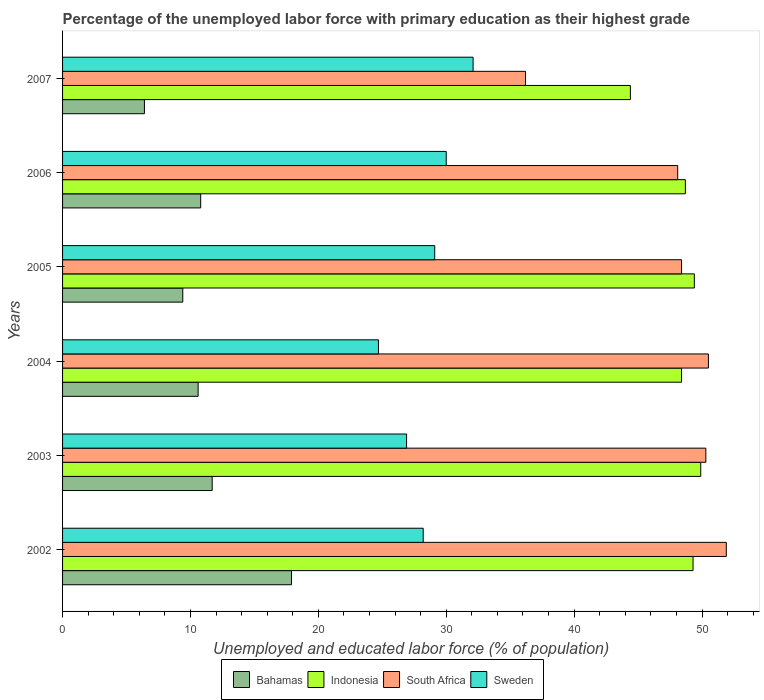How many different coloured bars are there?
Offer a very short reply. 4. Are the number of bars per tick equal to the number of legend labels?
Provide a succinct answer. Yes. Are the number of bars on each tick of the Y-axis equal?
Your answer should be very brief. Yes. How many bars are there on the 3rd tick from the top?
Make the answer very short. 4. What is the label of the 3rd group of bars from the top?
Give a very brief answer. 2005. What is the percentage of the unemployed labor force with primary education in Indonesia in 2002?
Provide a short and direct response. 49.3. Across all years, what is the maximum percentage of the unemployed labor force with primary education in Sweden?
Keep it short and to the point. 32.1. Across all years, what is the minimum percentage of the unemployed labor force with primary education in South Africa?
Ensure brevity in your answer.  36.2. In which year was the percentage of the unemployed labor force with primary education in South Africa minimum?
Offer a terse response. 2007. What is the total percentage of the unemployed labor force with primary education in Bahamas in the graph?
Your answer should be compact. 66.8. What is the difference between the percentage of the unemployed labor force with primary education in Bahamas in 2002 and that in 2005?
Keep it short and to the point. 8.5. What is the difference between the percentage of the unemployed labor force with primary education in Sweden in 2006 and the percentage of the unemployed labor force with primary education in South Africa in 2007?
Ensure brevity in your answer.  -6.2. What is the average percentage of the unemployed labor force with primary education in Sweden per year?
Provide a succinct answer. 28.5. In the year 2004, what is the difference between the percentage of the unemployed labor force with primary education in Indonesia and percentage of the unemployed labor force with primary education in Bahamas?
Make the answer very short. 37.8. In how many years, is the percentage of the unemployed labor force with primary education in Sweden greater than 32 %?
Offer a very short reply. 1. What is the ratio of the percentage of the unemployed labor force with primary education in South Africa in 2003 to that in 2007?
Give a very brief answer. 1.39. Is the percentage of the unemployed labor force with primary education in South Africa in 2005 less than that in 2006?
Keep it short and to the point. No. What is the difference between the highest and the second highest percentage of the unemployed labor force with primary education in Bahamas?
Ensure brevity in your answer.  6.2. What is the difference between the highest and the lowest percentage of the unemployed labor force with primary education in South Africa?
Provide a short and direct response. 15.7. In how many years, is the percentage of the unemployed labor force with primary education in Indonesia greater than the average percentage of the unemployed labor force with primary education in Indonesia taken over all years?
Provide a short and direct response. 5. Is the sum of the percentage of the unemployed labor force with primary education in South Africa in 2003 and 2007 greater than the maximum percentage of the unemployed labor force with primary education in Bahamas across all years?
Provide a succinct answer. Yes. Is it the case that in every year, the sum of the percentage of the unemployed labor force with primary education in South Africa and percentage of the unemployed labor force with primary education in Bahamas is greater than the sum of percentage of the unemployed labor force with primary education in Sweden and percentage of the unemployed labor force with primary education in Indonesia?
Ensure brevity in your answer.  Yes. What does the 2nd bar from the bottom in 2006 represents?
Make the answer very short. Indonesia. What is the difference between two consecutive major ticks on the X-axis?
Your answer should be very brief. 10. Are the values on the major ticks of X-axis written in scientific E-notation?
Make the answer very short. No. Does the graph contain any zero values?
Keep it short and to the point. No. Where does the legend appear in the graph?
Your answer should be compact. Bottom center. How many legend labels are there?
Ensure brevity in your answer.  4. What is the title of the graph?
Your response must be concise. Percentage of the unemployed labor force with primary education as their highest grade. What is the label or title of the X-axis?
Offer a very short reply. Unemployed and educated labor force (% of population). What is the label or title of the Y-axis?
Offer a very short reply. Years. What is the Unemployed and educated labor force (% of population) of Bahamas in 2002?
Ensure brevity in your answer.  17.9. What is the Unemployed and educated labor force (% of population) in Indonesia in 2002?
Make the answer very short. 49.3. What is the Unemployed and educated labor force (% of population) in South Africa in 2002?
Your answer should be very brief. 51.9. What is the Unemployed and educated labor force (% of population) of Sweden in 2002?
Offer a very short reply. 28.2. What is the Unemployed and educated labor force (% of population) in Bahamas in 2003?
Your answer should be very brief. 11.7. What is the Unemployed and educated labor force (% of population) in Indonesia in 2003?
Make the answer very short. 49.9. What is the Unemployed and educated labor force (% of population) in South Africa in 2003?
Keep it short and to the point. 50.3. What is the Unemployed and educated labor force (% of population) in Sweden in 2003?
Offer a terse response. 26.9. What is the Unemployed and educated labor force (% of population) of Bahamas in 2004?
Your answer should be compact. 10.6. What is the Unemployed and educated labor force (% of population) of Indonesia in 2004?
Give a very brief answer. 48.4. What is the Unemployed and educated labor force (% of population) in South Africa in 2004?
Ensure brevity in your answer.  50.5. What is the Unemployed and educated labor force (% of population) in Sweden in 2004?
Provide a succinct answer. 24.7. What is the Unemployed and educated labor force (% of population) of Bahamas in 2005?
Offer a terse response. 9.4. What is the Unemployed and educated labor force (% of population) of Indonesia in 2005?
Give a very brief answer. 49.4. What is the Unemployed and educated labor force (% of population) in South Africa in 2005?
Your answer should be very brief. 48.4. What is the Unemployed and educated labor force (% of population) in Sweden in 2005?
Provide a succinct answer. 29.1. What is the Unemployed and educated labor force (% of population) of Bahamas in 2006?
Provide a short and direct response. 10.8. What is the Unemployed and educated labor force (% of population) in Indonesia in 2006?
Your answer should be very brief. 48.7. What is the Unemployed and educated labor force (% of population) in South Africa in 2006?
Offer a terse response. 48.1. What is the Unemployed and educated labor force (% of population) in Sweden in 2006?
Ensure brevity in your answer.  30. What is the Unemployed and educated labor force (% of population) in Bahamas in 2007?
Make the answer very short. 6.4. What is the Unemployed and educated labor force (% of population) in Indonesia in 2007?
Ensure brevity in your answer.  44.4. What is the Unemployed and educated labor force (% of population) in South Africa in 2007?
Offer a very short reply. 36.2. What is the Unemployed and educated labor force (% of population) of Sweden in 2007?
Your response must be concise. 32.1. Across all years, what is the maximum Unemployed and educated labor force (% of population) in Bahamas?
Ensure brevity in your answer.  17.9. Across all years, what is the maximum Unemployed and educated labor force (% of population) of Indonesia?
Ensure brevity in your answer.  49.9. Across all years, what is the maximum Unemployed and educated labor force (% of population) of South Africa?
Ensure brevity in your answer.  51.9. Across all years, what is the maximum Unemployed and educated labor force (% of population) of Sweden?
Ensure brevity in your answer.  32.1. Across all years, what is the minimum Unemployed and educated labor force (% of population) in Bahamas?
Ensure brevity in your answer.  6.4. Across all years, what is the minimum Unemployed and educated labor force (% of population) in Indonesia?
Keep it short and to the point. 44.4. Across all years, what is the minimum Unemployed and educated labor force (% of population) in South Africa?
Offer a terse response. 36.2. Across all years, what is the minimum Unemployed and educated labor force (% of population) in Sweden?
Offer a terse response. 24.7. What is the total Unemployed and educated labor force (% of population) in Bahamas in the graph?
Offer a very short reply. 66.8. What is the total Unemployed and educated labor force (% of population) of Indonesia in the graph?
Offer a very short reply. 290.1. What is the total Unemployed and educated labor force (% of population) of South Africa in the graph?
Give a very brief answer. 285.4. What is the total Unemployed and educated labor force (% of population) of Sweden in the graph?
Your answer should be very brief. 171. What is the difference between the Unemployed and educated labor force (% of population) of Bahamas in 2002 and that in 2003?
Make the answer very short. 6.2. What is the difference between the Unemployed and educated labor force (% of population) in Sweden in 2002 and that in 2003?
Your response must be concise. 1.3. What is the difference between the Unemployed and educated labor force (% of population) in Indonesia in 2002 and that in 2004?
Your answer should be very brief. 0.9. What is the difference between the Unemployed and educated labor force (% of population) of South Africa in 2002 and that in 2004?
Your response must be concise. 1.4. What is the difference between the Unemployed and educated labor force (% of population) of Indonesia in 2002 and that in 2005?
Offer a terse response. -0.1. What is the difference between the Unemployed and educated labor force (% of population) in Sweden in 2002 and that in 2005?
Provide a short and direct response. -0.9. What is the difference between the Unemployed and educated labor force (% of population) of Indonesia in 2002 and that in 2006?
Keep it short and to the point. 0.6. What is the difference between the Unemployed and educated labor force (% of population) in Sweden in 2002 and that in 2006?
Your response must be concise. -1.8. What is the difference between the Unemployed and educated labor force (% of population) of Indonesia in 2002 and that in 2007?
Keep it short and to the point. 4.9. What is the difference between the Unemployed and educated labor force (% of population) of South Africa in 2003 and that in 2004?
Give a very brief answer. -0.2. What is the difference between the Unemployed and educated labor force (% of population) of Sweden in 2003 and that in 2004?
Your answer should be very brief. 2.2. What is the difference between the Unemployed and educated labor force (% of population) in South Africa in 2003 and that in 2005?
Provide a short and direct response. 1.9. What is the difference between the Unemployed and educated labor force (% of population) in Sweden in 2003 and that in 2005?
Your answer should be very brief. -2.2. What is the difference between the Unemployed and educated labor force (% of population) of Bahamas in 2003 and that in 2006?
Your answer should be compact. 0.9. What is the difference between the Unemployed and educated labor force (% of population) of Indonesia in 2003 and that in 2006?
Provide a succinct answer. 1.2. What is the difference between the Unemployed and educated labor force (% of population) of Sweden in 2003 and that in 2006?
Provide a short and direct response. -3.1. What is the difference between the Unemployed and educated labor force (% of population) in Bahamas in 2004 and that in 2005?
Your response must be concise. 1.2. What is the difference between the Unemployed and educated labor force (% of population) in South Africa in 2004 and that in 2005?
Offer a terse response. 2.1. What is the difference between the Unemployed and educated labor force (% of population) of Sweden in 2004 and that in 2005?
Provide a short and direct response. -4.4. What is the difference between the Unemployed and educated labor force (% of population) of Indonesia in 2004 and that in 2006?
Offer a terse response. -0.3. What is the difference between the Unemployed and educated labor force (% of population) of South Africa in 2004 and that in 2006?
Give a very brief answer. 2.4. What is the difference between the Unemployed and educated labor force (% of population) in Bahamas in 2004 and that in 2007?
Keep it short and to the point. 4.2. What is the difference between the Unemployed and educated labor force (% of population) in South Africa in 2004 and that in 2007?
Offer a very short reply. 14.3. What is the difference between the Unemployed and educated labor force (% of population) of Sweden in 2004 and that in 2007?
Provide a succinct answer. -7.4. What is the difference between the Unemployed and educated labor force (% of population) of Bahamas in 2005 and that in 2007?
Offer a very short reply. 3. What is the difference between the Unemployed and educated labor force (% of population) in Indonesia in 2005 and that in 2007?
Give a very brief answer. 5. What is the difference between the Unemployed and educated labor force (% of population) in Sweden in 2005 and that in 2007?
Your answer should be very brief. -3. What is the difference between the Unemployed and educated labor force (% of population) of Bahamas in 2006 and that in 2007?
Your answer should be very brief. 4.4. What is the difference between the Unemployed and educated labor force (% of population) of South Africa in 2006 and that in 2007?
Keep it short and to the point. 11.9. What is the difference between the Unemployed and educated labor force (% of population) of Sweden in 2006 and that in 2007?
Your response must be concise. -2.1. What is the difference between the Unemployed and educated labor force (% of population) of Bahamas in 2002 and the Unemployed and educated labor force (% of population) of Indonesia in 2003?
Offer a very short reply. -32. What is the difference between the Unemployed and educated labor force (% of population) of Bahamas in 2002 and the Unemployed and educated labor force (% of population) of South Africa in 2003?
Provide a succinct answer. -32.4. What is the difference between the Unemployed and educated labor force (% of population) in Indonesia in 2002 and the Unemployed and educated labor force (% of population) in Sweden in 2003?
Your answer should be compact. 22.4. What is the difference between the Unemployed and educated labor force (% of population) of Bahamas in 2002 and the Unemployed and educated labor force (% of population) of Indonesia in 2004?
Your answer should be compact. -30.5. What is the difference between the Unemployed and educated labor force (% of population) in Bahamas in 2002 and the Unemployed and educated labor force (% of population) in South Africa in 2004?
Ensure brevity in your answer.  -32.6. What is the difference between the Unemployed and educated labor force (% of population) in Indonesia in 2002 and the Unemployed and educated labor force (% of population) in Sweden in 2004?
Provide a succinct answer. 24.6. What is the difference between the Unemployed and educated labor force (% of population) in South Africa in 2002 and the Unemployed and educated labor force (% of population) in Sweden in 2004?
Provide a short and direct response. 27.2. What is the difference between the Unemployed and educated labor force (% of population) of Bahamas in 2002 and the Unemployed and educated labor force (% of population) of Indonesia in 2005?
Provide a short and direct response. -31.5. What is the difference between the Unemployed and educated labor force (% of population) of Bahamas in 2002 and the Unemployed and educated labor force (% of population) of South Africa in 2005?
Your answer should be compact. -30.5. What is the difference between the Unemployed and educated labor force (% of population) of Indonesia in 2002 and the Unemployed and educated labor force (% of population) of South Africa in 2005?
Make the answer very short. 0.9. What is the difference between the Unemployed and educated labor force (% of population) of Indonesia in 2002 and the Unemployed and educated labor force (% of population) of Sweden in 2005?
Your answer should be compact. 20.2. What is the difference between the Unemployed and educated labor force (% of population) of South Africa in 2002 and the Unemployed and educated labor force (% of population) of Sweden in 2005?
Your answer should be very brief. 22.8. What is the difference between the Unemployed and educated labor force (% of population) in Bahamas in 2002 and the Unemployed and educated labor force (% of population) in Indonesia in 2006?
Ensure brevity in your answer.  -30.8. What is the difference between the Unemployed and educated labor force (% of population) in Bahamas in 2002 and the Unemployed and educated labor force (% of population) in South Africa in 2006?
Your answer should be very brief. -30.2. What is the difference between the Unemployed and educated labor force (% of population) in Indonesia in 2002 and the Unemployed and educated labor force (% of population) in Sweden in 2006?
Provide a short and direct response. 19.3. What is the difference between the Unemployed and educated labor force (% of population) of South Africa in 2002 and the Unemployed and educated labor force (% of population) of Sweden in 2006?
Your response must be concise. 21.9. What is the difference between the Unemployed and educated labor force (% of population) of Bahamas in 2002 and the Unemployed and educated labor force (% of population) of Indonesia in 2007?
Ensure brevity in your answer.  -26.5. What is the difference between the Unemployed and educated labor force (% of population) of Bahamas in 2002 and the Unemployed and educated labor force (% of population) of South Africa in 2007?
Your answer should be very brief. -18.3. What is the difference between the Unemployed and educated labor force (% of population) in Bahamas in 2002 and the Unemployed and educated labor force (% of population) in Sweden in 2007?
Ensure brevity in your answer.  -14.2. What is the difference between the Unemployed and educated labor force (% of population) of South Africa in 2002 and the Unemployed and educated labor force (% of population) of Sweden in 2007?
Give a very brief answer. 19.8. What is the difference between the Unemployed and educated labor force (% of population) of Bahamas in 2003 and the Unemployed and educated labor force (% of population) of Indonesia in 2004?
Ensure brevity in your answer.  -36.7. What is the difference between the Unemployed and educated labor force (% of population) in Bahamas in 2003 and the Unemployed and educated labor force (% of population) in South Africa in 2004?
Provide a succinct answer. -38.8. What is the difference between the Unemployed and educated labor force (% of population) in Bahamas in 2003 and the Unemployed and educated labor force (% of population) in Sweden in 2004?
Ensure brevity in your answer.  -13. What is the difference between the Unemployed and educated labor force (% of population) of Indonesia in 2003 and the Unemployed and educated labor force (% of population) of Sweden in 2004?
Your answer should be very brief. 25.2. What is the difference between the Unemployed and educated labor force (% of population) in South Africa in 2003 and the Unemployed and educated labor force (% of population) in Sweden in 2004?
Offer a terse response. 25.6. What is the difference between the Unemployed and educated labor force (% of population) of Bahamas in 2003 and the Unemployed and educated labor force (% of population) of Indonesia in 2005?
Keep it short and to the point. -37.7. What is the difference between the Unemployed and educated labor force (% of population) in Bahamas in 2003 and the Unemployed and educated labor force (% of population) in South Africa in 2005?
Your answer should be compact. -36.7. What is the difference between the Unemployed and educated labor force (% of population) of Bahamas in 2003 and the Unemployed and educated labor force (% of population) of Sweden in 2005?
Keep it short and to the point. -17.4. What is the difference between the Unemployed and educated labor force (% of population) in Indonesia in 2003 and the Unemployed and educated labor force (% of population) in Sweden in 2005?
Ensure brevity in your answer.  20.8. What is the difference between the Unemployed and educated labor force (% of population) in South Africa in 2003 and the Unemployed and educated labor force (% of population) in Sweden in 2005?
Ensure brevity in your answer.  21.2. What is the difference between the Unemployed and educated labor force (% of population) of Bahamas in 2003 and the Unemployed and educated labor force (% of population) of Indonesia in 2006?
Make the answer very short. -37. What is the difference between the Unemployed and educated labor force (% of population) of Bahamas in 2003 and the Unemployed and educated labor force (% of population) of South Africa in 2006?
Your response must be concise. -36.4. What is the difference between the Unemployed and educated labor force (% of population) of Bahamas in 2003 and the Unemployed and educated labor force (% of population) of Sweden in 2006?
Give a very brief answer. -18.3. What is the difference between the Unemployed and educated labor force (% of population) of Indonesia in 2003 and the Unemployed and educated labor force (% of population) of South Africa in 2006?
Provide a succinct answer. 1.8. What is the difference between the Unemployed and educated labor force (% of population) in South Africa in 2003 and the Unemployed and educated labor force (% of population) in Sweden in 2006?
Keep it short and to the point. 20.3. What is the difference between the Unemployed and educated labor force (% of population) in Bahamas in 2003 and the Unemployed and educated labor force (% of population) in Indonesia in 2007?
Your answer should be very brief. -32.7. What is the difference between the Unemployed and educated labor force (% of population) in Bahamas in 2003 and the Unemployed and educated labor force (% of population) in South Africa in 2007?
Your answer should be compact. -24.5. What is the difference between the Unemployed and educated labor force (% of population) of Bahamas in 2003 and the Unemployed and educated labor force (% of population) of Sweden in 2007?
Make the answer very short. -20.4. What is the difference between the Unemployed and educated labor force (% of population) in Indonesia in 2003 and the Unemployed and educated labor force (% of population) in Sweden in 2007?
Your answer should be compact. 17.8. What is the difference between the Unemployed and educated labor force (% of population) of Bahamas in 2004 and the Unemployed and educated labor force (% of population) of Indonesia in 2005?
Make the answer very short. -38.8. What is the difference between the Unemployed and educated labor force (% of population) in Bahamas in 2004 and the Unemployed and educated labor force (% of population) in South Africa in 2005?
Give a very brief answer. -37.8. What is the difference between the Unemployed and educated labor force (% of population) in Bahamas in 2004 and the Unemployed and educated labor force (% of population) in Sweden in 2005?
Ensure brevity in your answer.  -18.5. What is the difference between the Unemployed and educated labor force (% of population) in Indonesia in 2004 and the Unemployed and educated labor force (% of population) in Sweden in 2005?
Your answer should be compact. 19.3. What is the difference between the Unemployed and educated labor force (% of population) of South Africa in 2004 and the Unemployed and educated labor force (% of population) of Sweden in 2005?
Make the answer very short. 21.4. What is the difference between the Unemployed and educated labor force (% of population) of Bahamas in 2004 and the Unemployed and educated labor force (% of population) of Indonesia in 2006?
Offer a terse response. -38.1. What is the difference between the Unemployed and educated labor force (% of population) of Bahamas in 2004 and the Unemployed and educated labor force (% of population) of South Africa in 2006?
Offer a terse response. -37.5. What is the difference between the Unemployed and educated labor force (% of population) in Bahamas in 2004 and the Unemployed and educated labor force (% of population) in Sweden in 2006?
Your answer should be compact. -19.4. What is the difference between the Unemployed and educated labor force (% of population) of Indonesia in 2004 and the Unemployed and educated labor force (% of population) of South Africa in 2006?
Your answer should be compact. 0.3. What is the difference between the Unemployed and educated labor force (% of population) in Indonesia in 2004 and the Unemployed and educated labor force (% of population) in Sweden in 2006?
Make the answer very short. 18.4. What is the difference between the Unemployed and educated labor force (% of population) in Bahamas in 2004 and the Unemployed and educated labor force (% of population) in Indonesia in 2007?
Your answer should be very brief. -33.8. What is the difference between the Unemployed and educated labor force (% of population) in Bahamas in 2004 and the Unemployed and educated labor force (% of population) in South Africa in 2007?
Give a very brief answer. -25.6. What is the difference between the Unemployed and educated labor force (% of population) of Bahamas in 2004 and the Unemployed and educated labor force (% of population) of Sweden in 2007?
Provide a succinct answer. -21.5. What is the difference between the Unemployed and educated labor force (% of population) in Bahamas in 2005 and the Unemployed and educated labor force (% of population) in Indonesia in 2006?
Give a very brief answer. -39.3. What is the difference between the Unemployed and educated labor force (% of population) in Bahamas in 2005 and the Unemployed and educated labor force (% of population) in South Africa in 2006?
Give a very brief answer. -38.7. What is the difference between the Unemployed and educated labor force (% of population) in Bahamas in 2005 and the Unemployed and educated labor force (% of population) in Sweden in 2006?
Offer a very short reply. -20.6. What is the difference between the Unemployed and educated labor force (% of population) of Indonesia in 2005 and the Unemployed and educated labor force (% of population) of South Africa in 2006?
Give a very brief answer. 1.3. What is the difference between the Unemployed and educated labor force (% of population) of South Africa in 2005 and the Unemployed and educated labor force (% of population) of Sweden in 2006?
Offer a very short reply. 18.4. What is the difference between the Unemployed and educated labor force (% of population) of Bahamas in 2005 and the Unemployed and educated labor force (% of population) of Indonesia in 2007?
Your answer should be very brief. -35. What is the difference between the Unemployed and educated labor force (% of population) of Bahamas in 2005 and the Unemployed and educated labor force (% of population) of South Africa in 2007?
Provide a succinct answer. -26.8. What is the difference between the Unemployed and educated labor force (% of population) of Bahamas in 2005 and the Unemployed and educated labor force (% of population) of Sweden in 2007?
Offer a terse response. -22.7. What is the difference between the Unemployed and educated labor force (% of population) of Indonesia in 2005 and the Unemployed and educated labor force (% of population) of South Africa in 2007?
Provide a short and direct response. 13.2. What is the difference between the Unemployed and educated labor force (% of population) of Bahamas in 2006 and the Unemployed and educated labor force (% of population) of Indonesia in 2007?
Offer a terse response. -33.6. What is the difference between the Unemployed and educated labor force (% of population) of Bahamas in 2006 and the Unemployed and educated labor force (% of population) of South Africa in 2007?
Offer a terse response. -25.4. What is the difference between the Unemployed and educated labor force (% of population) of Bahamas in 2006 and the Unemployed and educated labor force (% of population) of Sweden in 2007?
Give a very brief answer. -21.3. What is the difference between the Unemployed and educated labor force (% of population) of Indonesia in 2006 and the Unemployed and educated labor force (% of population) of South Africa in 2007?
Offer a very short reply. 12.5. What is the difference between the Unemployed and educated labor force (% of population) of Indonesia in 2006 and the Unemployed and educated labor force (% of population) of Sweden in 2007?
Offer a terse response. 16.6. What is the average Unemployed and educated labor force (% of population) of Bahamas per year?
Your answer should be compact. 11.13. What is the average Unemployed and educated labor force (% of population) in Indonesia per year?
Make the answer very short. 48.35. What is the average Unemployed and educated labor force (% of population) of South Africa per year?
Keep it short and to the point. 47.57. What is the average Unemployed and educated labor force (% of population) in Sweden per year?
Your answer should be very brief. 28.5. In the year 2002, what is the difference between the Unemployed and educated labor force (% of population) in Bahamas and Unemployed and educated labor force (% of population) in Indonesia?
Ensure brevity in your answer.  -31.4. In the year 2002, what is the difference between the Unemployed and educated labor force (% of population) of Bahamas and Unemployed and educated labor force (% of population) of South Africa?
Your answer should be very brief. -34. In the year 2002, what is the difference between the Unemployed and educated labor force (% of population) in Bahamas and Unemployed and educated labor force (% of population) in Sweden?
Offer a very short reply. -10.3. In the year 2002, what is the difference between the Unemployed and educated labor force (% of population) of Indonesia and Unemployed and educated labor force (% of population) of South Africa?
Provide a short and direct response. -2.6. In the year 2002, what is the difference between the Unemployed and educated labor force (% of population) of Indonesia and Unemployed and educated labor force (% of population) of Sweden?
Provide a succinct answer. 21.1. In the year 2002, what is the difference between the Unemployed and educated labor force (% of population) of South Africa and Unemployed and educated labor force (% of population) of Sweden?
Your response must be concise. 23.7. In the year 2003, what is the difference between the Unemployed and educated labor force (% of population) in Bahamas and Unemployed and educated labor force (% of population) in Indonesia?
Keep it short and to the point. -38.2. In the year 2003, what is the difference between the Unemployed and educated labor force (% of population) in Bahamas and Unemployed and educated labor force (% of population) in South Africa?
Your answer should be very brief. -38.6. In the year 2003, what is the difference between the Unemployed and educated labor force (% of population) of Bahamas and Unemployed and educated labor force (% of population) of Sweden?
Provide a short and direct response. -15.2. In the year 2003, what is the difference between the Unemployed and educated labor force (% of population) of South Africa and Unemployed and educated labor force (% of population) of Sweden?
Your answer should be very brief. 23.4. In the year 2004, what is the difference between the Unemployed and educated labor force (% of population) in Bahamas and Unemployed and educated labor force (% of population) in Indonesia?
Give a very brief answer. -37.8. In the year 2004, what is the difference between the Unemployed and educated labor force (% of population) in Bahamas and Unemployed and educated labor force (% of population) in South Africa?
Provide a short and direct response. -39.9. In the year 2004, what is the difference between the Unemployed and educated labor force (% of population) of Bahamas and Unemployed and educated labor force (% of population) of Sweden?
Provide a succinct answer. -14.1. In the year 2004, what is the difference between the Unemployed and educated labor force (% of population) in Indonesia and Unemployed and educated labor force (% of population) in South Africa?
Your response must be concise. -2.1. In the year 2004, what is the difference between the Unemployed and educated labor force (% of population) of Indonesia and Unemployed and educated labor force (% of population) of Sweden?
Make the answer very short. 23.7. In the year 2004, what is the difference between the Unemployed and educated labor force (% of population) in South Africa and Unemployed and educated labor force (% of population) in Sweden?
Provide a succinct answer. 25.8. In the year 2005, what is the difference between the Unemployed and educated labor force (% of population) of Bahamas and Unemployed and educated labor force (% of population) of Indonesia?
Provide a short and direct response. -40. In the year 2005, what is the difference between the Unemployed and educated labor force (% of population) of Bahamas and Unemployed and educated labor force (% of population) of South Africa?
Offer a very short reply. -39. In the year 2005, what is the difference between the Unemployed and educated labor force (% of population) of Bahamas and Unemployed and educated labor force (% of population) of Sweden?
Offer a terse response. -19.7. In the year 2005, what is the difference between the Unemployed and educated labor force (% of population) in Indonesia and Unemployed and educated labor force (% of population) in South Africa?
Ensure brevity in your answer.  1. In the year 2005, what is the difference between the Unemployed and educated labor force (% of population) of Indonesia and Unemployed and educated labor force (% of population) of Sweden?
Ensure brevity in your answer.  20.3. In the year 2005, what is the difference between the Unemployed and educated labor force (% of population) in South Africa and Unemployed and educated labor force (% of population) in Sweden?
Offer a very short reply. 19.3. In the year 2006, what is the difference between the Unemployed and educated labor force (% of population) in Bahamas and Unemployed and educated labor force (% of population) in Indonesia?
Give a very brief answer. -37.9. In the year 2006, what is the difference between the Unemployed and educated labor force (% of population) in Bahamas and Unemployed and educated labor force (% of population) in South Africa?
Provide a short and direct response. -37.3. In the year 2006, what is the difference between the Unemployed and educated labor force (% of population) in Bahamas and Unemployed and educated labor force (% of population) in Sweden?
Keep it short and to the point. -19.2. In the year 2006, what is the difference between the Unemployed and educated labor force (% of population) in South Africa and Unemployed and educated labor force (% of population) in Sweden?
Provide a succinct answer. 18.1. In the year 2007, what is the difference between the Unemployed and educated labor force (% of population) of Bahamas and Unemployed and educated labor force (% of population) of Indonesia?
Provide a succinct answer. -38. In the year 2007, what is the difference between the Unemployed and educated labor force (% of population) of Bahamas and Unemployed and educated labor force (% of population) of South Africa?
Provide a succinct answer. -29.8. In the year 2007, what is the difference between the Unemployed and educated labor force (% of population) of Bahamas and Unemployed and educated labor force (% of population) of Sweden?
Keep it short and to the point. -25.7. In the year 2007, what is the difference between the Unemployed and educated labor force (% of population) in South Africa and Unemployed and educated labor force (% of population) in Sweden?
Offer a very short reply. 4.1. What is the ratio of the Unemployed and educated labor force (% of population) of Bahamas in 2002 to that in 2003?
Give a very brief answer. 1.53. What is the ratio of the Unemployed and educated labor force (% of population) in South Africa in 2002 to that in 2003?
Keep it short and to the point. 1.03. What is the ratio of the Unemployed and educated labor force (% of population) in Sweden in 2002 to that in 2003?
Ensure brevity in your answer.  1.05. What is the ratio of the Unemployed and educated labor force (% of population) of Bahamas in 2002 to that in 2004?
Provide a short and direct response. 1.69. What is the ratio of the Unemployed and educated labor force (% of population) of Indonesia in 2002 to that in 2004?
Give a very brief answer. 1.02. What is the ratio of the Unemployed and educated labor force (% of population) of South Africa in 2002 to that in 2004?
Keep it short and to the point. 1.03. What is the ratio of the Unemployed and educated labor force (% of population) in Sweden in 2002 to that in 2004?
Give a very brief answer. 1.14. What is the ratio of the Unemployed and educated labor force (% of population) in Bahamas in 2002 to that in 2005?
Provide a short and direct response. 1.9. What is the ratio of the Unemployed and educated labor force (% of population) of Indonesia in 2002 to that in 2005?
Provide a short and direct response. 1. What is the ratio of the Unemployed and educated labor force (% of population) of South Africa in 2002 to that in 2005?
Your answer should be very brief. 1.07. What is the ratio of the Unemployed and educated labor force (% of population) in Sweden in 2002 to that in 2005?
Ensure brevity in your answer.  0.97. What is the ratio of the Unemployed and educated labor force (% of population) in Bahamas in 2002 to that in 2006?
Offer a terse response. 1.66. What is the ratio of the Unemployed and educated labor force (% of population) in Indonesia in 2002 to that in 2006?
Your answer should be very brief. 1.01. What is the ratio of the Unemployed and educated labor force (% of population) of South Africa in 2002 to that in 2006?
Ensure brevity in your answer.  1.08. What is the ratio of the Unemployed and educated labor force (% of population) in Bahamas in 2002 to that in 2007?
Keep it short and to the point. 2.8. What is the ratio of the Unemployed and educated labor force (% of population) of Indonesia in 2002 to that in 2007?
Provide a succinct answer. 1.11. What is the ratio of the Unemployed and educated labor force (% of population) in South Africa in 2002 to that in 2007?
Keep it short and to the point. 1.43. What is the ratio of the Unemployed and educated labor force (% of population) in Sweden in 2002 to that in 2007?
Offer a very short reply. 0.88. What is the ratio of the Unemployed and educated labor force (% of population) of Bahamas in 2003 to that in 2004?
Give a very brief answer. 1.1. What is the ratio of the Unemployed and educated labor force (% of population) of Indonesia in 2003 to that in 2004?
Provide a succinct answer. 1.03. What is the ratio of the Unemployed and educated labor force (% of population) of Sweden in 2003 to that in 2004?
Keep it short and to the point. 1.09. What is the ratio of the Unemployed and educated labor force (% of population) in Bahamas in 2003 to that in 2005?
Ensure brevity in your answer.  1.24. What is the ratio of the Unemployed and educated labor force (% of population) of South Africa in 2003 to that in 2005?
Offer a terse response. 1.04. What is the ratio of the Unemployed and educated labor force (% of population) of Sweden in 2003 to that in 2005?
Provide a succinct answer. 0.92. What is the ratio of the Unemployed and educated labor force (% of population) in Bahamas in 2003 to that in 2006?
Make the answer very short. 1.08. What is the ratio of the Unemployed and educated labor force (% of population) of Indonesia in 2003 to that in 2006?
Make the answer very short. 1.02. What is the ratio of the Unemployed and educated labor force (% of population) of South Africa in 2003 to that in 2006?
Your answer should be compact. 1.05. What is the ratio of the Unemployed and educated labor force (% of population) in Sweden in 2003 to that in 2006?
Provide a succinct answer. 0.9. What is the ratio of the Unemployed and educated labor force (% of population) of Bahamas in 2003 to that in 2007?
Ensure brevity in your answer.  1.83. What is the ratio of the Unemployed and educated labor force (% of population) of Indonesia in 2003 to that in 2007?
Keep it short and to the point. 1.12. What is the ratio of the Unemployed and educated labor force (% of population) of South Africa in 2003 to that in 2007?
Provide a succinct answer. 1.39. What is the ratio of the Unemployed and educated labor force (% of population) in Sweden in 2003 to that in 2007?
Your answer should be very brief. 0.84. What is the ratio of the Unemployed and educated labor force (% of population) of Bahamas in 2004 to that in 2005?
Make the answer very short. 1.13. What is the ratio of the Unemployed and educated labor force (% of population) in Indonesia in 2004 to that in 2005?
Offer a very short reply. 0.98. What is the ratio of the Unemployed and educated labor force (% of population) of South Africa in 2004 to that in 2005?
Provide a succinct answer. 1.04. What is the ratio of the Unemployed and educated labor force (% of population) in Sweden in 2004 to that in 2005?
Provide a short and direct response. 0.85. What is the ratio of the Unemployed and educated labor force (% of population) of Bahamas in 2004 to that in 2006?
Offer a very short reply. 0.98. What is the ratio of the Unemployed and educated labor force (% of population) of South Africa in 2004 to that in 2006?
Provide a short and direct response. 1.05. What is the ratio of the Unemployed and educated labor force (% of population) in Sweden in 2004 to that in 2006?
Keep it short and to the point. 0.82. What is the ratio of the Unemployed and educated labor force (% of population) of Bahamas in 2004 to that in 2007?
Make the answer very short. 1.66. What is the ratio of the Unemployed and educated labor force (% of population) in Indonesia in 2004 to that in 2007?
Provide a succinct answer. 1.09. What is the ratio of the Unemployed and educated labor force (% of population) of South Africa in 2004 to that in 2007?
Give a very brief answer. 1.4. What is the ratio of the Unemployed and educated labor force (% of population) of Sweden in 2004 to that in 2007?
Ensure brevity in your answer.  0.77. What is the ratio of the Unemployed and educated labor force (% of population) in Bahamas in 2005 to that in 2006?
Your response must be concise. 0.87. What is the ratio of the Unemployed and educated labor force (% of population) of Indonesia in 2005 to that in 2006?
Your answer should be very brief. 1.01. What is the ratio of the Unemployed and educated labor force (% of population) in South Africa in 2005 to that in 2006?
Your answer should be compact. 1.01. What is the ratio of the Unemployed and educated labor force (% of population) in Sweden in 2005 to that in 2006?
Ensure brevity in your answer.  0.97. What is the ratio of the Unemployed and educated labor force (% of population) in Bahamas in 2005 to that in 2007?
Offer a terse response. 1.47. What is the ratio of the Unemployed and educated labor force (% of population) in Indonesia in 2005 to that in 2007?
Ensure brevity in your answer.  1.11. What is the ratio of the Unemployed and educated labor force (% of population) in South Africa in 2005 to that in 2007?
Keep it short and to the point. 1.34. What is the ratio of the Unemployed and educated labor force (% of population) of Sweden in 2005 to that in 2007?
Ensure brevity in your answer.  0.91. What is the ratio of the Unemployed and educated labor force (% of population) of Bahamas in 2006 to that in 2007?
Offer a very short reply. 1.69. What is the ratio of the Unemployed and educated labor force (% of population) in Indonesia in 2006 to that in 2007?
Give a very brief answer. 1.1. What is the ratio of the Unemployed and educated labor force (% of population) in South Africa in 2006 to that in 2007?
Your answer should be very brief. 1.33. What is the ratio of the Unemployed and educated labor force (% of population) in Sweden in 2006 to that in 2007?
Ensure brevity in your answer.  0.93. What is the difference between the highest and the second highest Unemployed and educated labor force (% of population) of Indonesia?
Your answer should be compact. 0.5. What is the difference between the highest and the lowest Unemployed and educated labor force (% of population) of Bahamas?
Ensure brevity in your answer.  11.5. What is the difference between the highest and the lowest Unemployed and educated labor force (% of population) of South Africa?
Offer a very short reply. 15.7. What is the difference between the highest and the lowest Unemployed and educated labor force (% of population) of Sweden?
Make the answer very short. 7.4. 